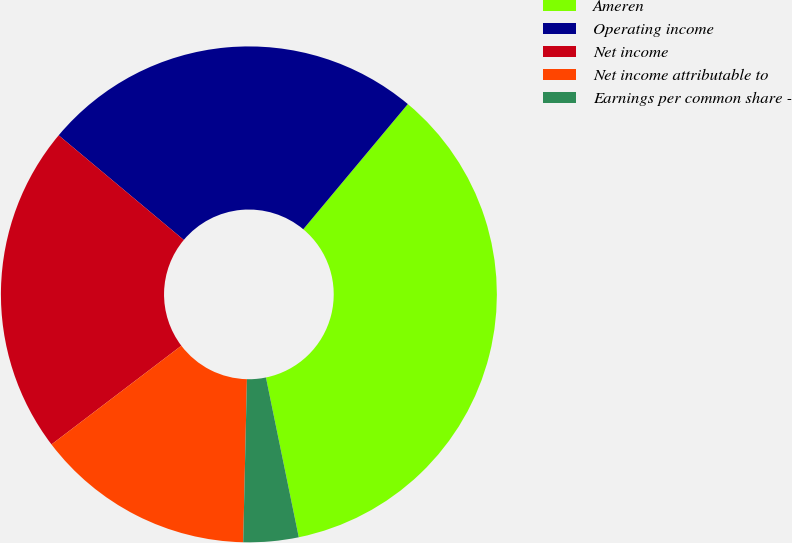Convert chart to OTSL. <chart><loc_0><loc_0><loc_500><loc_500><pie_chart><fcel>Ameren<fcel>Operating income<fcel>Net income<fcel>Net income attributable to<fcel>Earnings per common share -<nl><fcel>35.7%<fcel>24.99%<fcel>21.43%<fcel>14.29%<fcel>3.59%<nl></chart> 